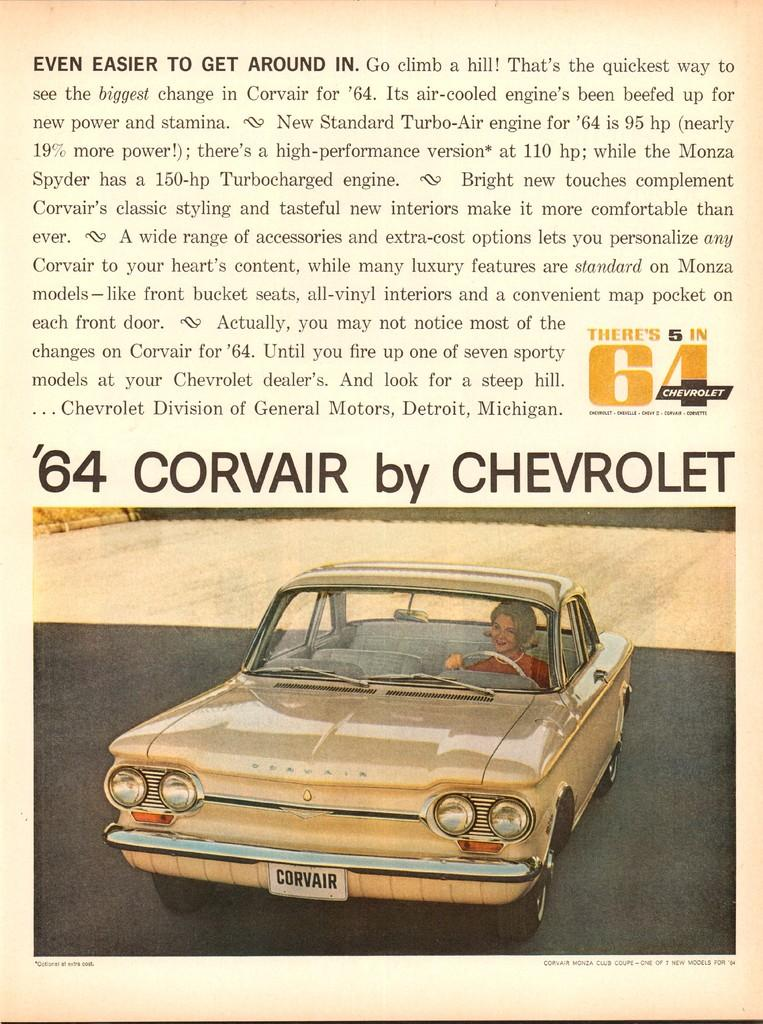What is the main subject of the image? The main subject of the image is an advertisement. How many seats are visible in the image? There are no seats visible in the image; it features an advertisement. Is there a house depicted in the advertisement? There is no house depicted in the advertisement; it is an advertisement without any reference to a house. 